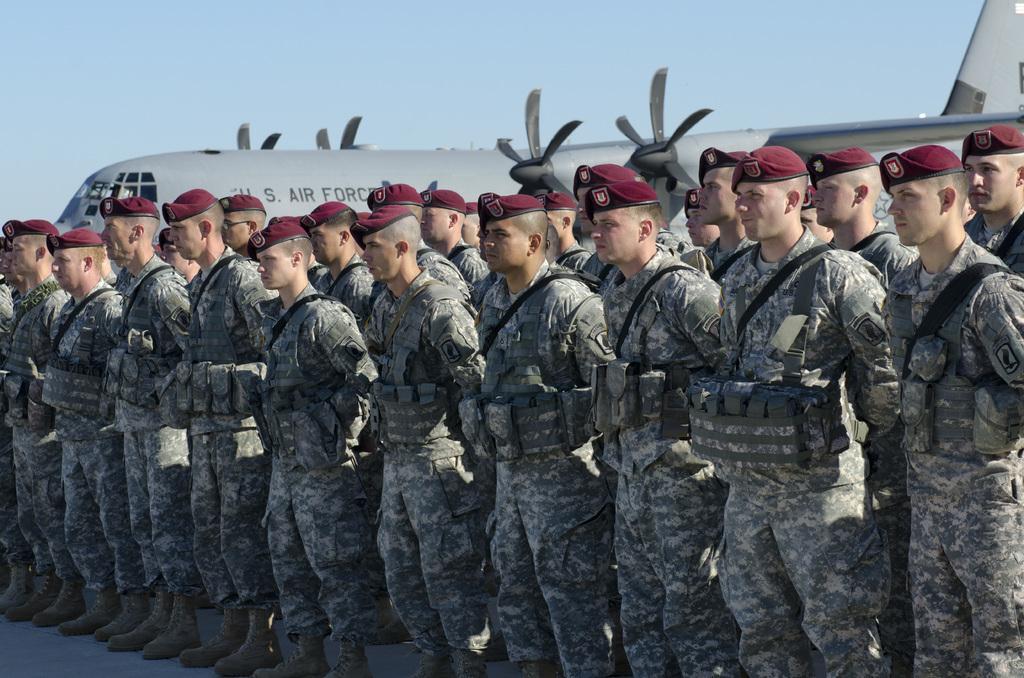Can you describe this image briefly? In the picture I can see group of people are standing on the ground. These people are wearing uniforms and hats. In the background I can see the sky and an aeroplane. 